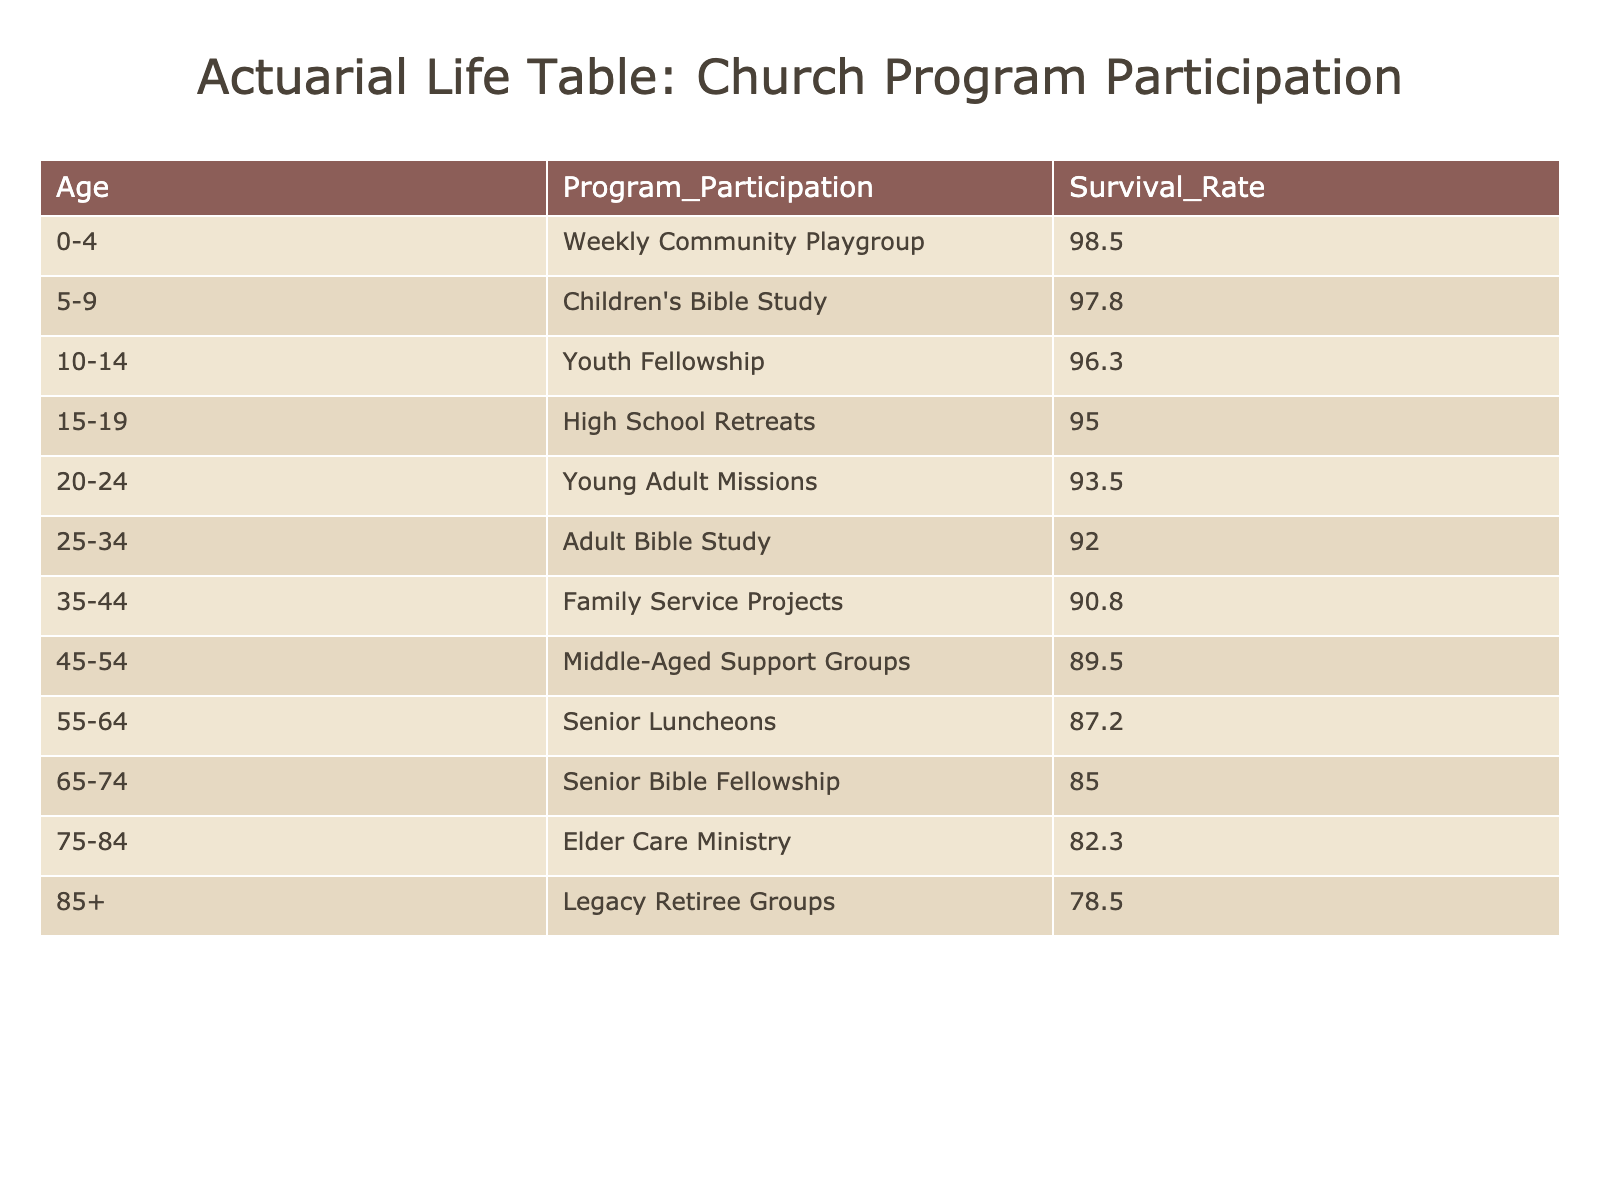What is the survival rate for the Elder Care Ministry program? The survival rate for the Elder Care Ministry program is directly listed in the table under the 75-84 age category, which shows a survival rate of 82.3.
Answer: 82.3 Which program has the highest survival rate? By reviewing the survival rates across all age groups and programs, the Weekly Community Playgroup, with a survival rate of 98.5, is the highest.
Answer: Weekly Community Playgroup What is the difference in survival rates between the Young Adult Missions and the Senior Bible Fellowship? Looking at the survival rates, Young Adult Missions has 93.5 and Senior Bible Fellowship has 85.0. The difference can be calculated as 93.5 - 85.0 = 8.5.
Answer: 8.5 True or False: The survival rate for the Legacy Retiree Groups is higher than that of the Senior Luncheons. The Legacy Retiree Groups has a survival rate of 78.5 and Senior Luncheons has 87.2. Since 78.5 is less than 87.2, the statement is false.
Answer: False What is the average survival rate of all the programs for parishioners aged 55 and older? The programs for ages 55-64 (87.2), 65-74 (85.0), 75-84 (82.3), and 85+ (78.5) need to be averaged. Summing these gives: 87.2 + 85.0 + 82.3 + 78.5 = 333. The average is then 333 / 4 = 83.25.
Answer: 83.25 How many programs have survival rates above 90? By examining the table, Weekly Community Playgroup (98.5), Children's Bible Study (97.8), Youth Fellowship (96.3), High School Retreats (95.0), and Young Adult Missions (93.5) are all above 90. Counting these, there are 5 programs.
Answer: 5 What percentage of the programs have survival rates below 85? Programs with survival rates below 85 are Elder Care Ministry (82.3) and Legacy Retiree Groups (78.5), totaling 2 programs. Since there are 12 programs total, the percentage is (2 / 12) * 100 = 16.67%.
Answer: 16.67% True or False: Adult Bible Study has a higher survival rate than Middle-Aged Support Groups. Reviewing the table shows that Adult Bible Study has a survival rate of 92.0 and Middle-Aged Support Groups has 89.5. Since 92.0 is greater than 89.5, the statement is true.
Answer: True 